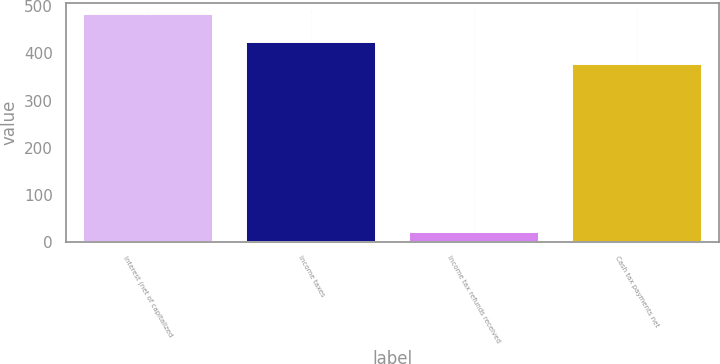Convert chart. <chart><loc_0><loc_0><loc_500><loc_500><bar_chart><fcel>Interest (net of capitalized<fcel>Income taxes<fcel>Income tax refunds received<fcel>Cash tax payments net<nl><fcel>484<fcel>423.4<fcel>20<fcel>377<nl></chart> 